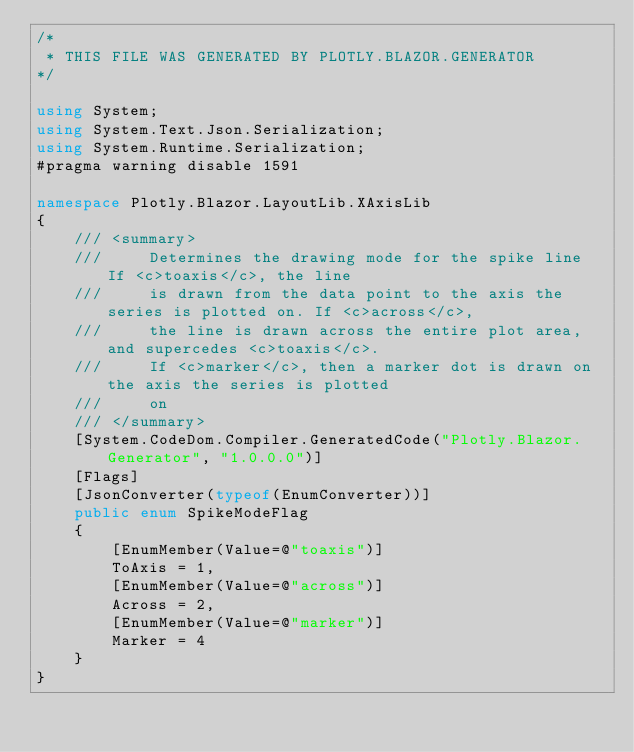<code> <loc_0><loc_0><loc_500><loc_500><_C#_>/*
 * THIS FILE WAS GENERATED BY PLOTLY.BLAZOR.GENERATOR
*/

using System;
using System.Text.Json.Serialization;
using System.Runtime.Serialization;
#pragma warning disable 1591

namespace Plotly.Blazor.LayoutLib.XAxisLib
{
    /// <summary>
    ///     Determines the drawing mode for the spike line If <c>toaxis</c>, the line
    ///     is drawn from the data point to the axis the  series is plotted on. If <c>across</c>,
    ///     the line is drawn across the entire plot area, and supercedes <c>toaxis</c>.
    ///     If <c>marker</c>, then a marker dot is drawn on the axis the series is plotted
    ///     on
    /// </summary>
    [System.CodeDom.Compiler.GeneratedCode("Plotly.Blazor.Generator", "1.0.0.0")]
    [Flags]
    [JsonConverter(typeof(EnumConverter))]
    public enum SpikeModeFlag
    {
        [EnumMember(Value=@"toaxis")]
        ToAxis = 1,
        [EnumMember(Value=@"across")]
        Across = 2,
        [EnumMember(Value=@"marker")]
        Marker = 4
    }
}</code> 